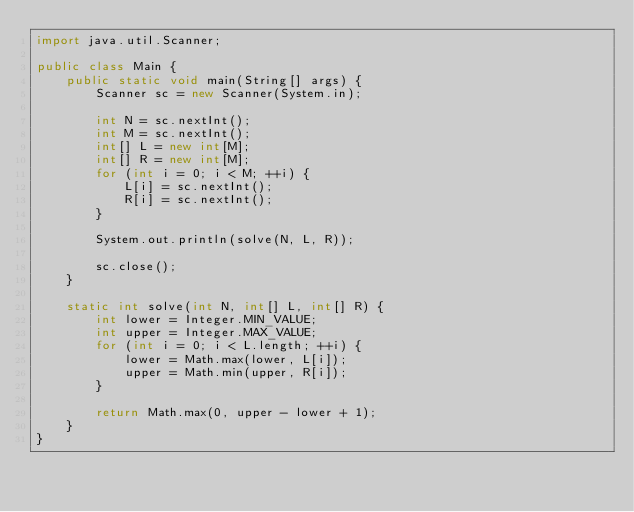<code> <loc_0><loc_0><loc_500><loc_500><_Java_>import java.util.Scanner;

public class Main {
    public static void main(String[] args) {
        Scanner sc = new Scanner(System.in);

        int N = sc.nextInt();
        int M = sc.nextInt();
        int[] L = new int[M];
        int[] R = new int[M];
        for (int i = 0; i < M; ++i) {
            L[i] = sc.nextInt();
            R[i] = sc.nextInt();
        }

        System.out.println(solve(N, L, R));

        sc.close();
    }

    static int solve(int N, int[] L, int[] R) {
        int lower = Integer.MIN_VALUE;
        int upper = Integer.MAX_VALUE;
        for (int i = 0; i < L.length; ++i) {
            lower = Math.max(lower, L[i]);
            upper = Math.min(upper, R[i]);
        }

        return Math.max(0, upper - lower + 1);
    }
}</code> 